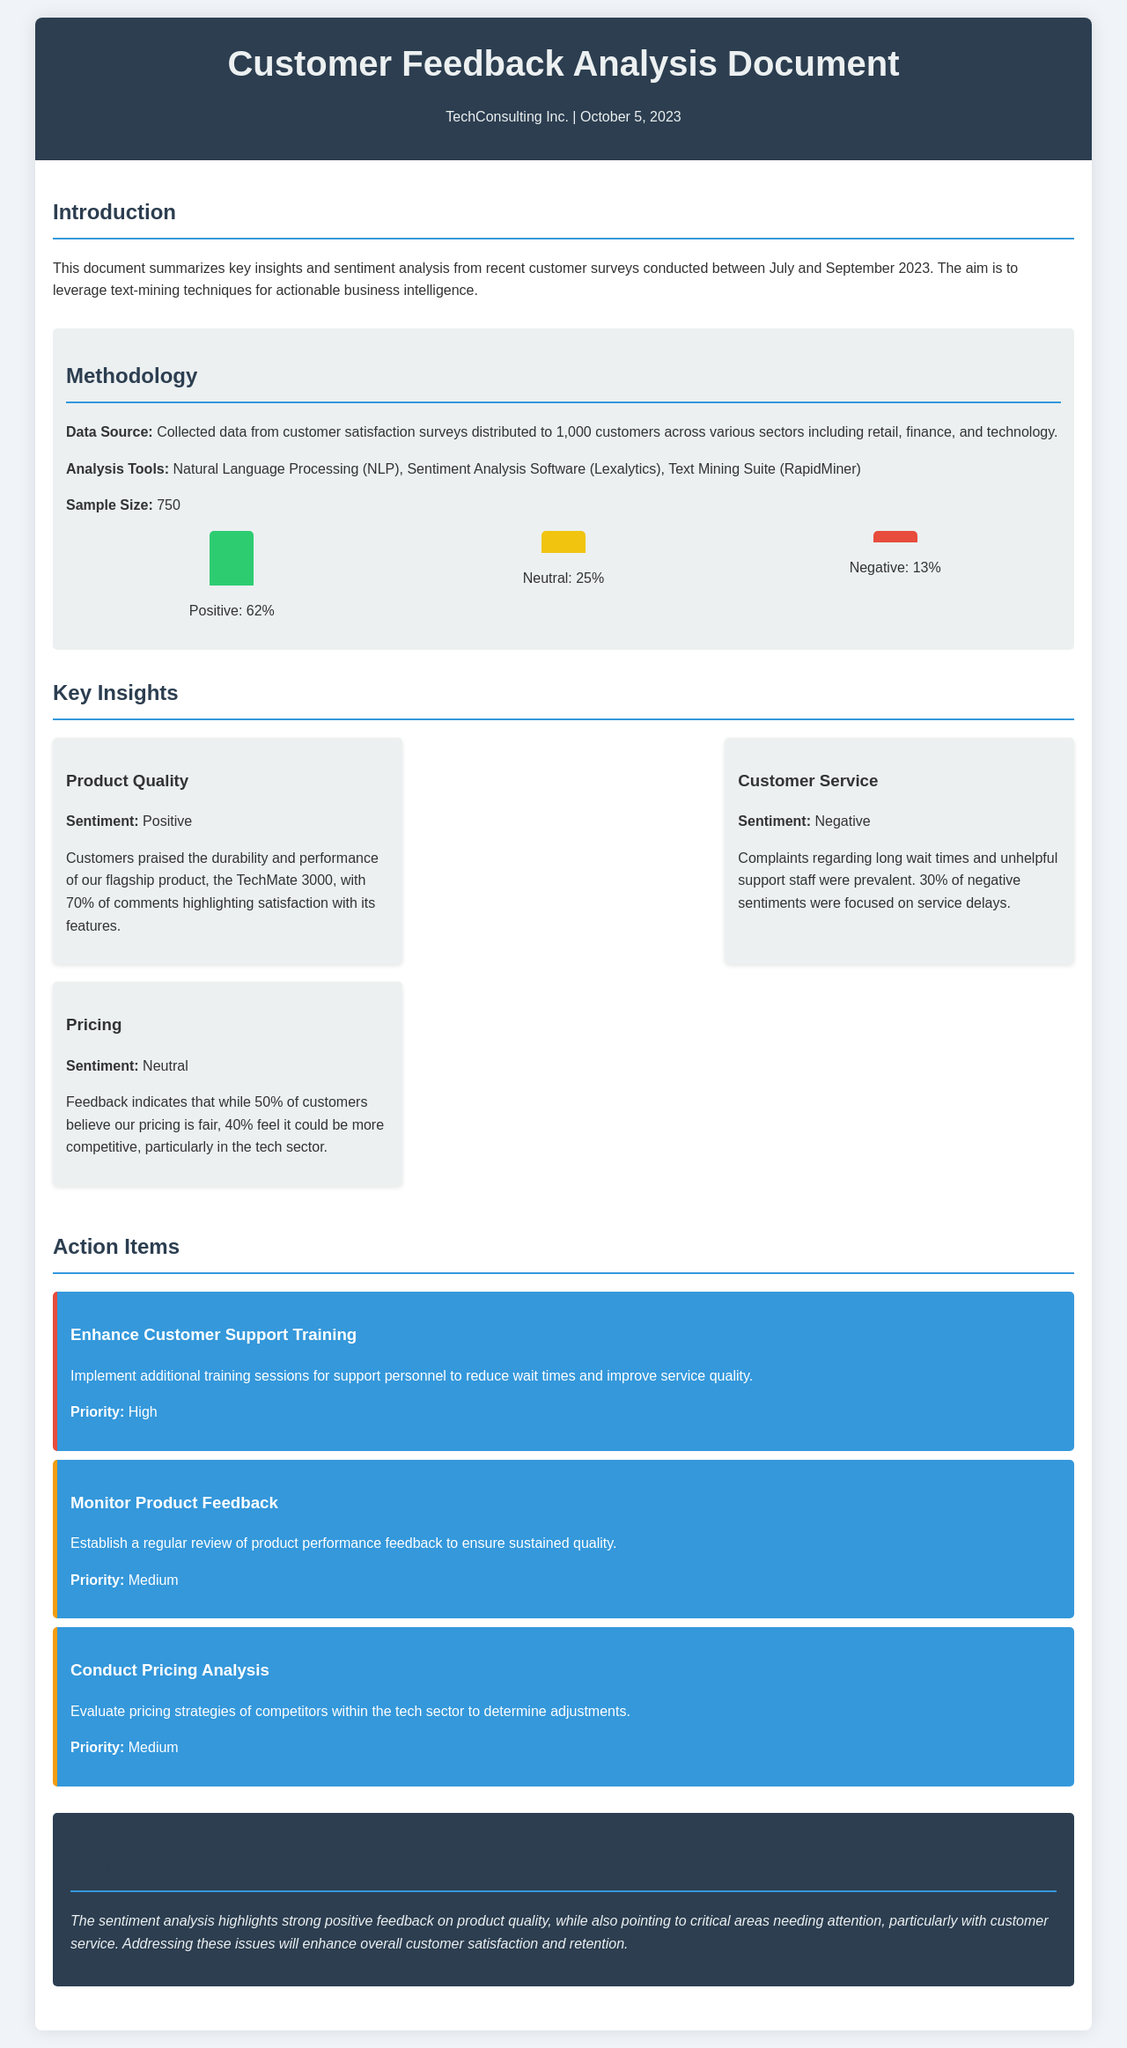What is the total sample size? The document states that the sample size for the analysis is 750 customers.
Answer: 750 What percentage of positive sentiment was recorded? The document indicates that 62% of the feedback was categorized as positive sentiment.
Answer: 62% Which product received the highest praise? The insights section states that the TechMate 3000 was highlighted for its durability and performance.
Answer: TechMate 3000 What was the main complaint regarding customer service? The document mentions that complaints were prevalent regarding long wait times and unhelpful support staff.
Answer: Long wait times What action item has the highest priority? The action items section states that enhancing customer support training is marked with high priority.
Answer: Enhance Customer Support Training What percentage of customers believe pricing is fair? The document mentions that 50% of customers feel that the pricing is fair.
Answer: 50% What are the tools used for the analysis? The methodology section lists Natural Language Processing, Sentiment Analysis Software, and Text Mining Suite as the analysis tools used.
Answer: Natural Language Processing, Sentiment Analysis Software, Text Mining Suite What is the overall conclusion about customer service? The conclusion highlights that critical areas needing attention involve customer service issues affecting satisfaction.
Answer: Critical areas needing attention What is the sentiment analysis percentage for neutral feedback? The document states that 25% of the feedback was categorized as neutral sentiment.
Answer: 25% 